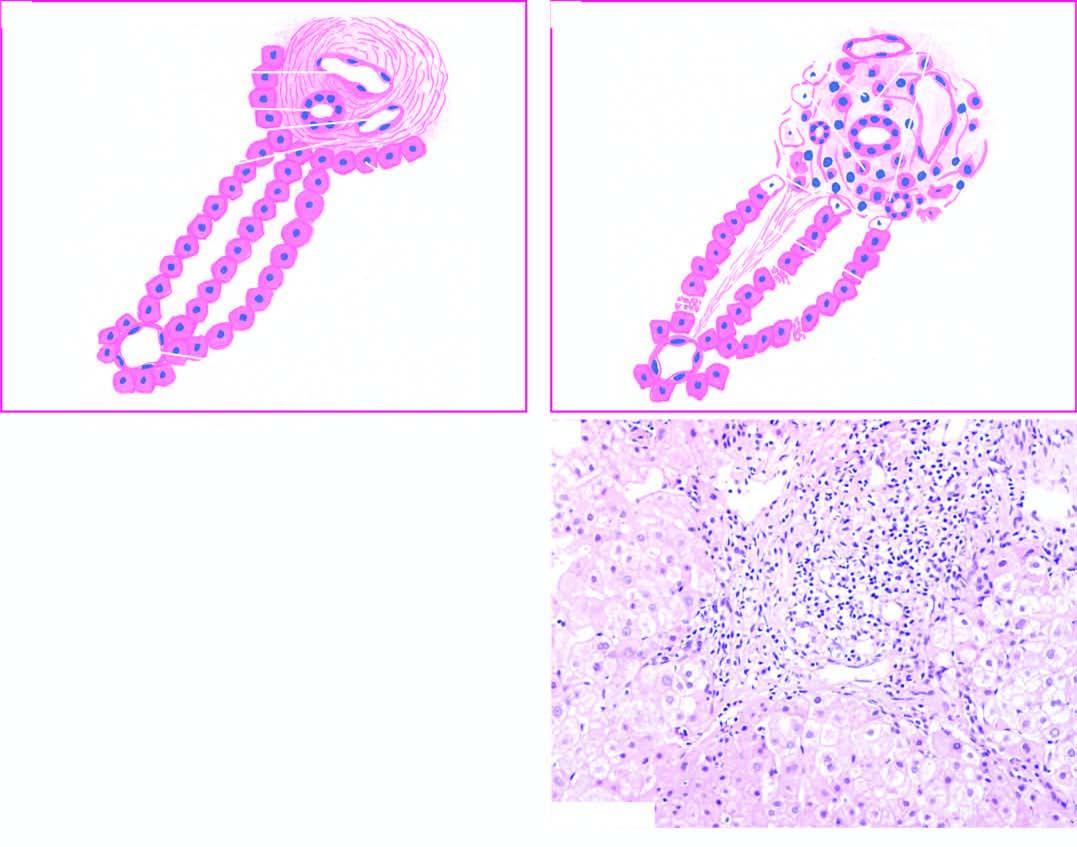s details contrasted with normal morphology?
Answer the question using a single word or phrase. No 